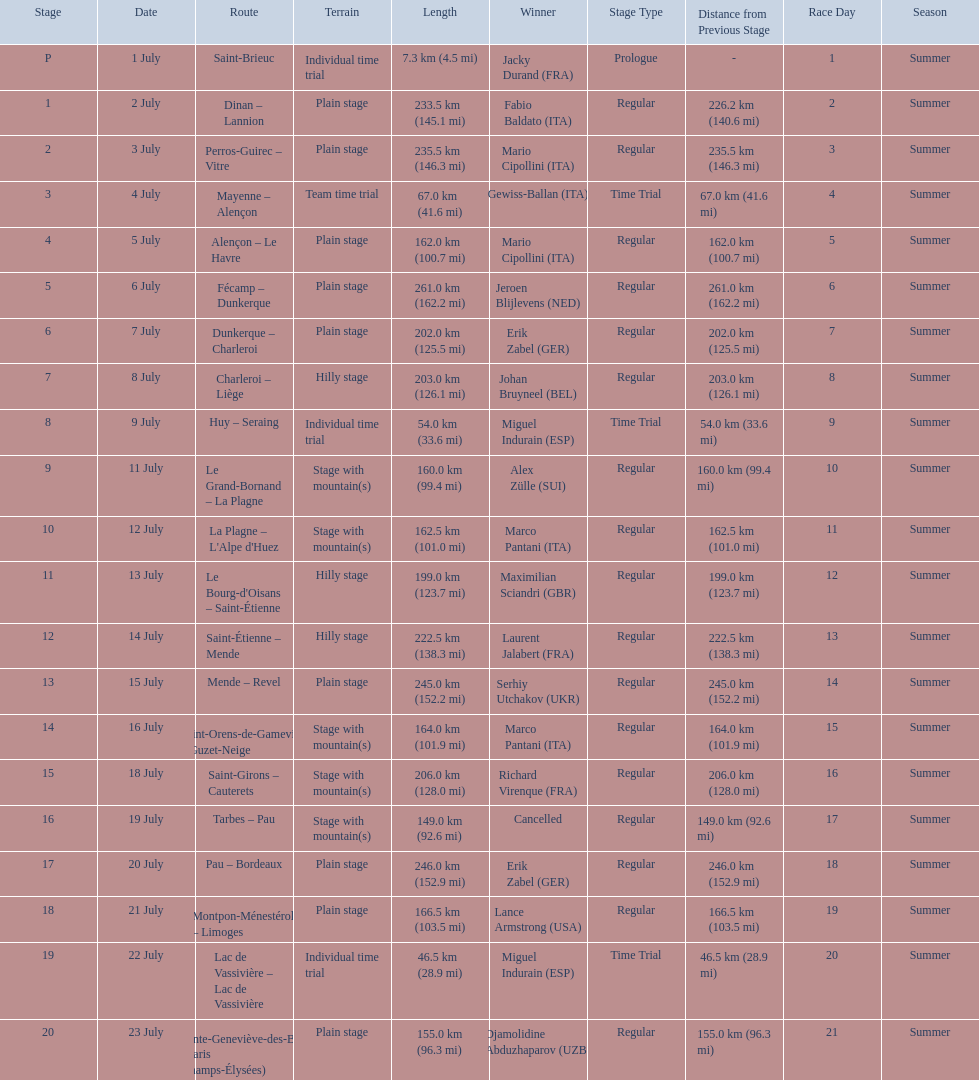What were the dates of the 1995 tour de france? 1 July, 2 July, 3 July, 4 July, 5 July, 6 July, 7 July, 8 July, 9 July, 11 July, 12 July, 13 July, 14 July, 15 July, 16 July, 18 July, 19 July, 20 July, 21 July, 22 July, 23 July. What was the length for july 8th? 203.0 km (126.1 mi). 